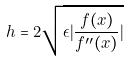<formula> <loc_0><loc_0><loc_500><loc_500>h = 2 \sqrt { \epsilon | \frac { f ( x ) } { f ^ { \prime \prime } ( x ) } | }</formula> 